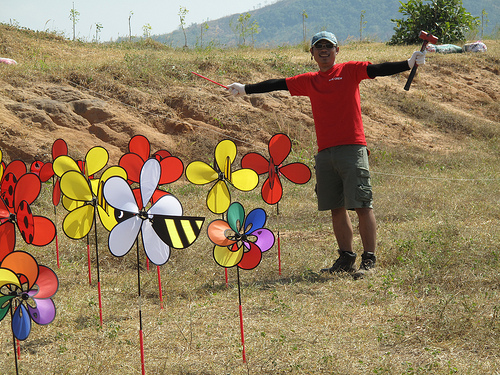<image>
Is the windmill next to the man? Yes. The windmill is positioned adjacent to the man, located nearby in the same general area. 